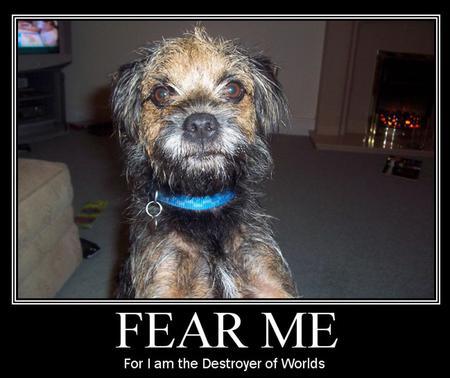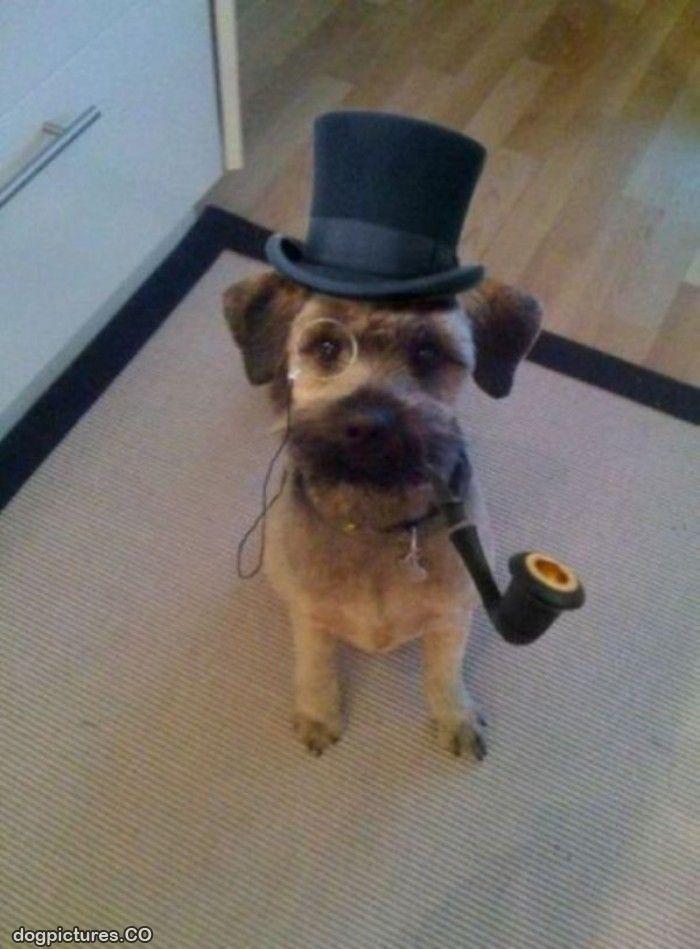The first image is the image on the left, the second image is the image on the right. For the images shown, is this caption "One little dog is wearing a clothing prop." true? Answer yes or no. Yes. The first image is the image on the left, the second image is the image on the right. For the images displayed, is the sentence "One dog is wearing an article of clothing." factually correct? Answer yes or no. Yes. 